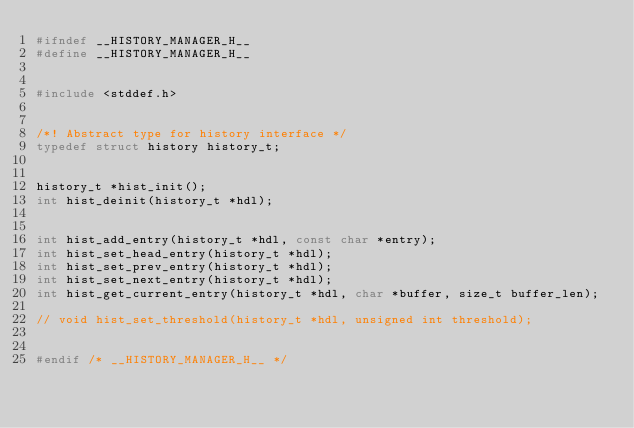Convert code to text. <code><loc_0><loc_0><loc_500><loc_500><_C_>#ifndef __HISTORY_MANAGER_H__
#define __HISTORY_MANAGER_H__


#include <stddef.h>


/*! Abstract type for history interface */
typedef struct history history_t;


history_t *hist_init();
int hist_deinit(history_t *hdl);


int hist_add_entry(history_t *hdl, const char *entry);
int hist_set_head_entry(history_t *hdl);
int hist_set_prev_entry(history_t *hdl);
int hist_set_next_entry(history_t *hdl);
int hist_get_current_entry(history_t *hdl, char *buffer, size_t buffer_len);

// void hist_set_threshold(history_t *hdl, unsigned int threshold);


#endif /* __HISTORY_MANAGER_H__ */

</code> 